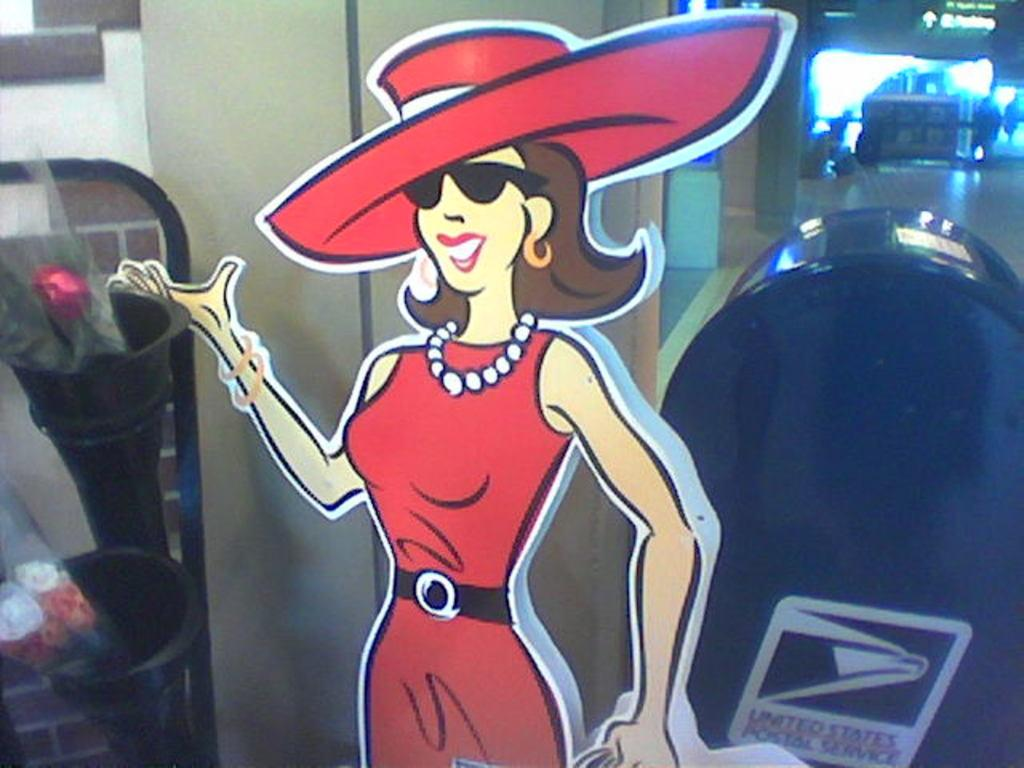<image>
Provide a brief description of the given image. A cut out of a woman in a big red hat is by a United States mailbox. 